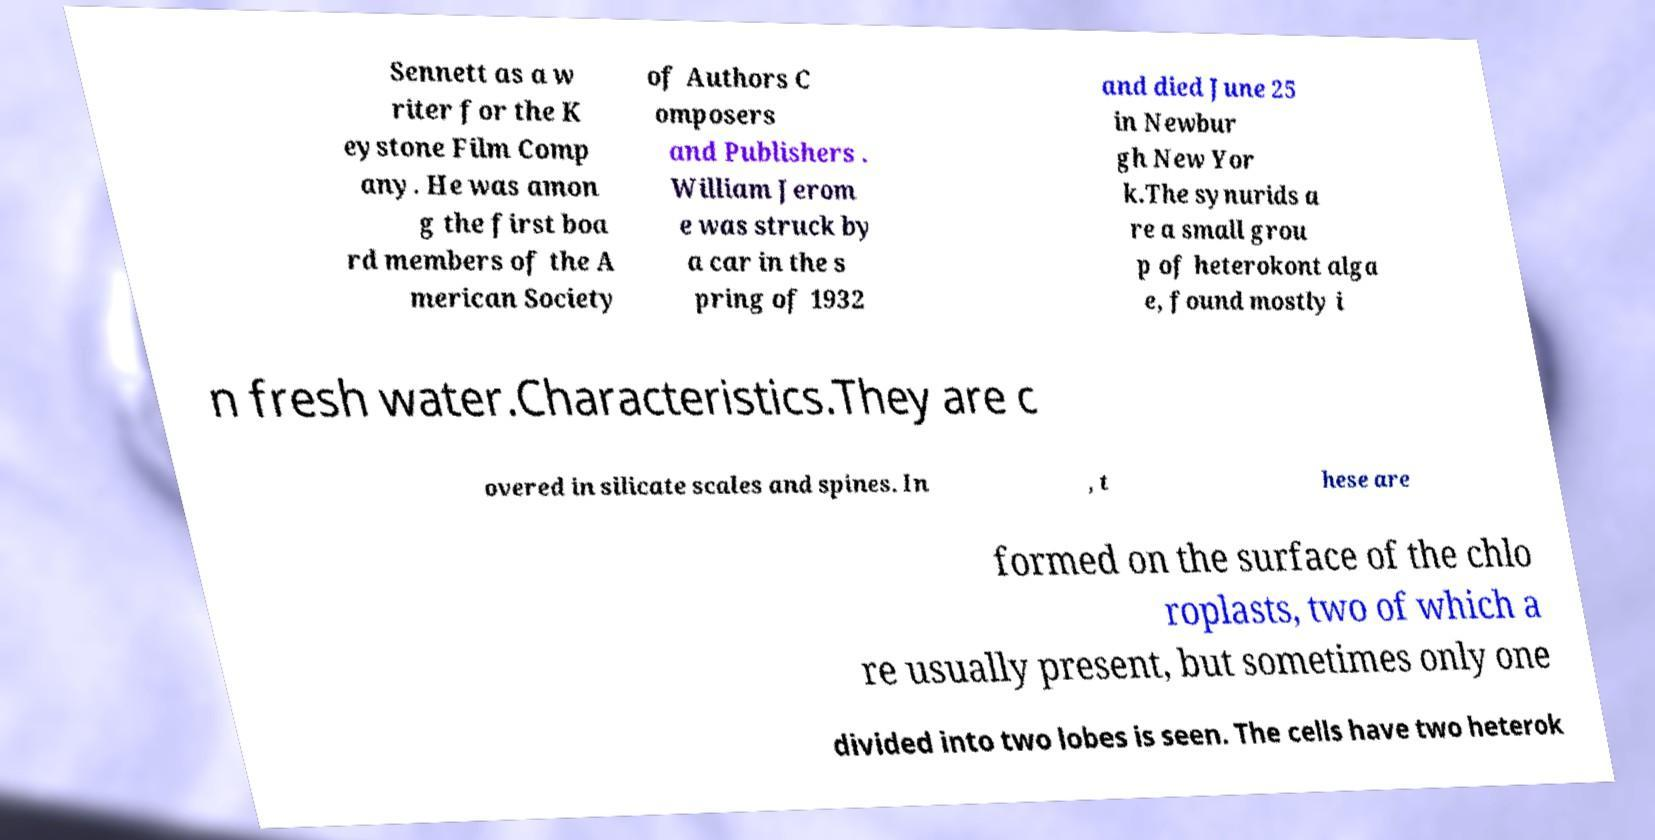Could you extract and type out the text from this image? Sennett as a w riter for the K eystone Film Comp any. He was amon g the first boa rd members of the A merican Society of Authors C omposers and Publishers . William Jerom e was struck by a car in the s pring of 1932 and died June 25 in Newbur gh New Yor k.The synurids a re a small grou p of heterokont alga e, found mostly i n fresh water.Characteristics.They are c overed in silicate scales and spines. In , t hese are formed on the surface of the chlo roplasts, two of which a re usually present, but sometimes only one divided into two lobes is seen. The cells have two heterok 